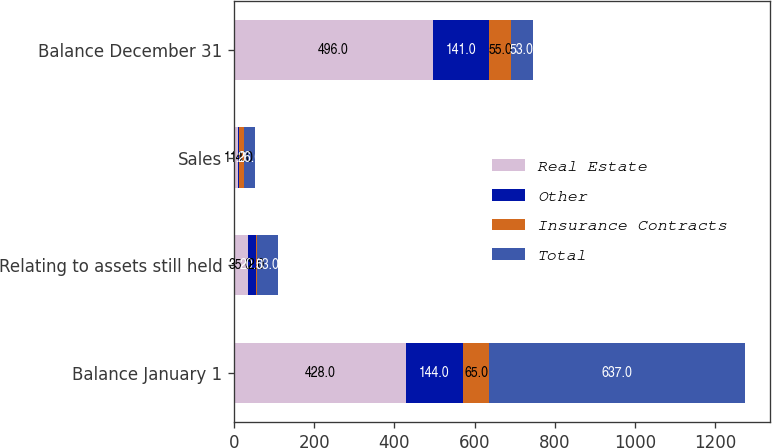Convert chart to OTSL. <chart><loc_0><loc_0><loc_500><loc_500><stacked_bar_chart><ecel><fcel>Balance January 1<fcel>Relating to assets still held<fcel>Sales<fcel>Balance December 31<nl><fcel>Real Estate<fcel>428<fcel>35<fcel>11<fcel>496<nl><fcel>Other<fcel>144<fcel>20<fcel>1<fcel>141<nl><fcel>Insurance Contracts<fcel>65<fcel>2<fcel>14<fcel>55<nl><fcel>Total<fcel>637<fcel>53<fcel>26<fcel>53<nl></chart> 